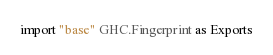<code> <loc_0><loc_0><loc_500><loc_500><_Haskell_>
import "base" GHC.Fingerprint as Exports
</code> 